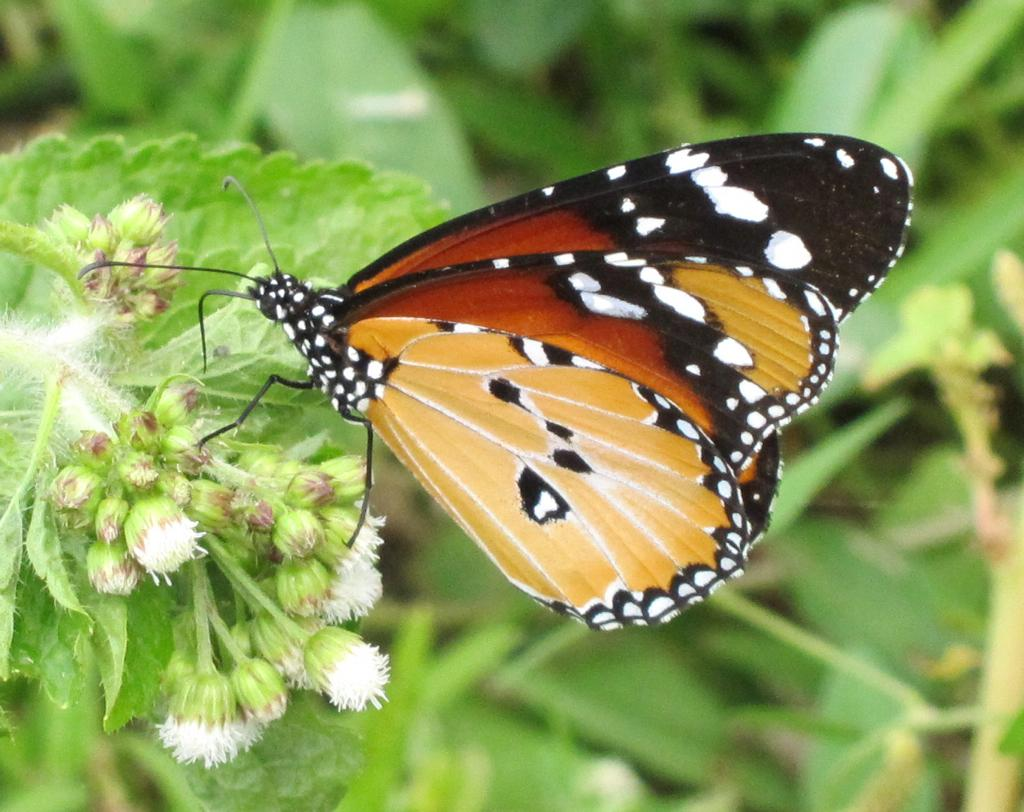What is the main subject of the image? The main subject of the image is plants. Can you describe the plants in the image? There are many plants in the image, and some of them have flowers and buds. Is there any wildlife present in the image? Yes, a butterfly is sitting on a plant in the image. What type of stew is being prepared on the desk in the image? There is no stew or desk present in the image; it features plants and a butterfly. How many volleyballs are visible in the image? There are no volleyballs present in the image. 